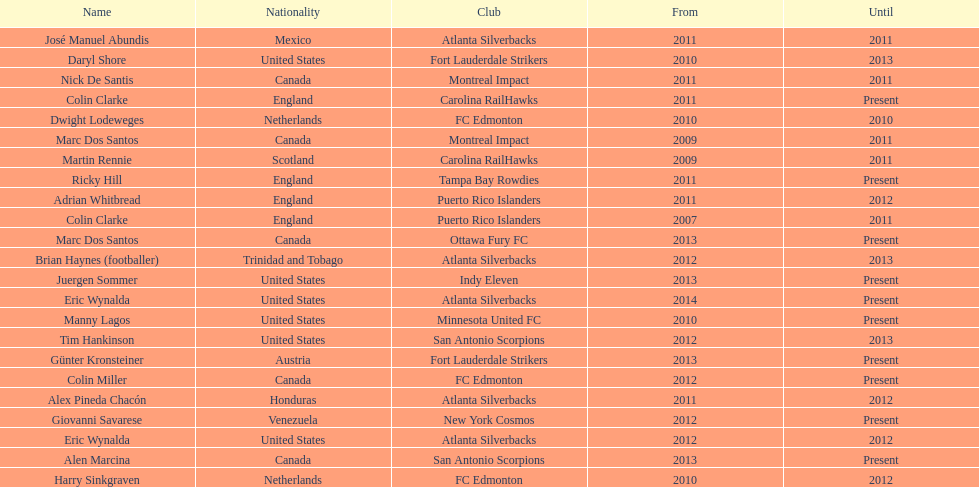How long did colin clarke coach the puerto rico islanders for? 4 years. Could you help me parse every detail presented in this table? {'header': ['Name', 'Nationality', 'Club', 'From', 'Until'], 'rows': [['José Manuel Abundis', 'Mexico', 'Atlanta Silverbacks', '2011', '2011'], ['Daryl Shore', 'United States', 'Fort Lauderdale Strikers', '2010', '2013'], ['Nick De Santis', 'Canada', 'Montreal Impact', '2011', '2011'], ['Colin Clarke', 'England', 'Carolina RailHawks', '2011', 'Present'], ['Dwight Lodeweges', 'Netherlands', 'FC Edmonton', '2010', '2010'], ['Marc Dos Santos', 'Canada', 'Montreal Impact', '2009', '2011'], ['Martin Rennie', 'Scotland', 'Carolina RailHawks', '2009', '2011'], ['Ricky Hill', 'England', 'Tampa Bay Rowdies', '2011', 'Present'], ['Adrian Whitbread', 'England', 'Puerto Rico Islanders', '2011', '2012'], ['Colin Clarke', 'England', 'Puerto Rico Islanders', '2007', '2011'], ['Marc Dos Santos', 'Canada', 'Ottawa Fury FC', '2013', 'Present'], ['Brian Haynes (footballer)', 'Trinidad and Tobago', 'Atlanta Silverbacks', '2012', '2013'], ['Juergen Sommer', 'United States', 'Indy Eleven', '2013', 'Present'], ['Eric Wynalda', 'United States', 'Atlanta Silverbacks', '2014', 'Present'], ['Manny Lagos', 'United States', 'Minnesota United FC', '2010', 'Present'], ['Tim Hankinson', 'United States', 'San Antonio Scorpions', '2012', '2013'], ['Günter Kronsteiner', 'Austria', 'Fort Lauderdale Strikers', '2013', 'Present'], ['Colin Miller', 'Canada', 'FC Edmonton', '2012', 'Present'], ['Alex Pineda Chacón', 'Honduras', 'Atlanta Silverbacks', '2011', '2012'], ['Giovanni Savarese', 'Venezuela', 'New York Cosmos', '2012', 'Present'], ['Eric Wynalda', 'United States', 'Atlanta Silverbacks', '2012', '2012'], ['Alen Marcina', 'Canada', 'San Antonio Scorpions', '2013', 'Present'], ['Harry Sinkgraven', 'Netherlands', 'FC Edmonton', '2010', '2012']]} 